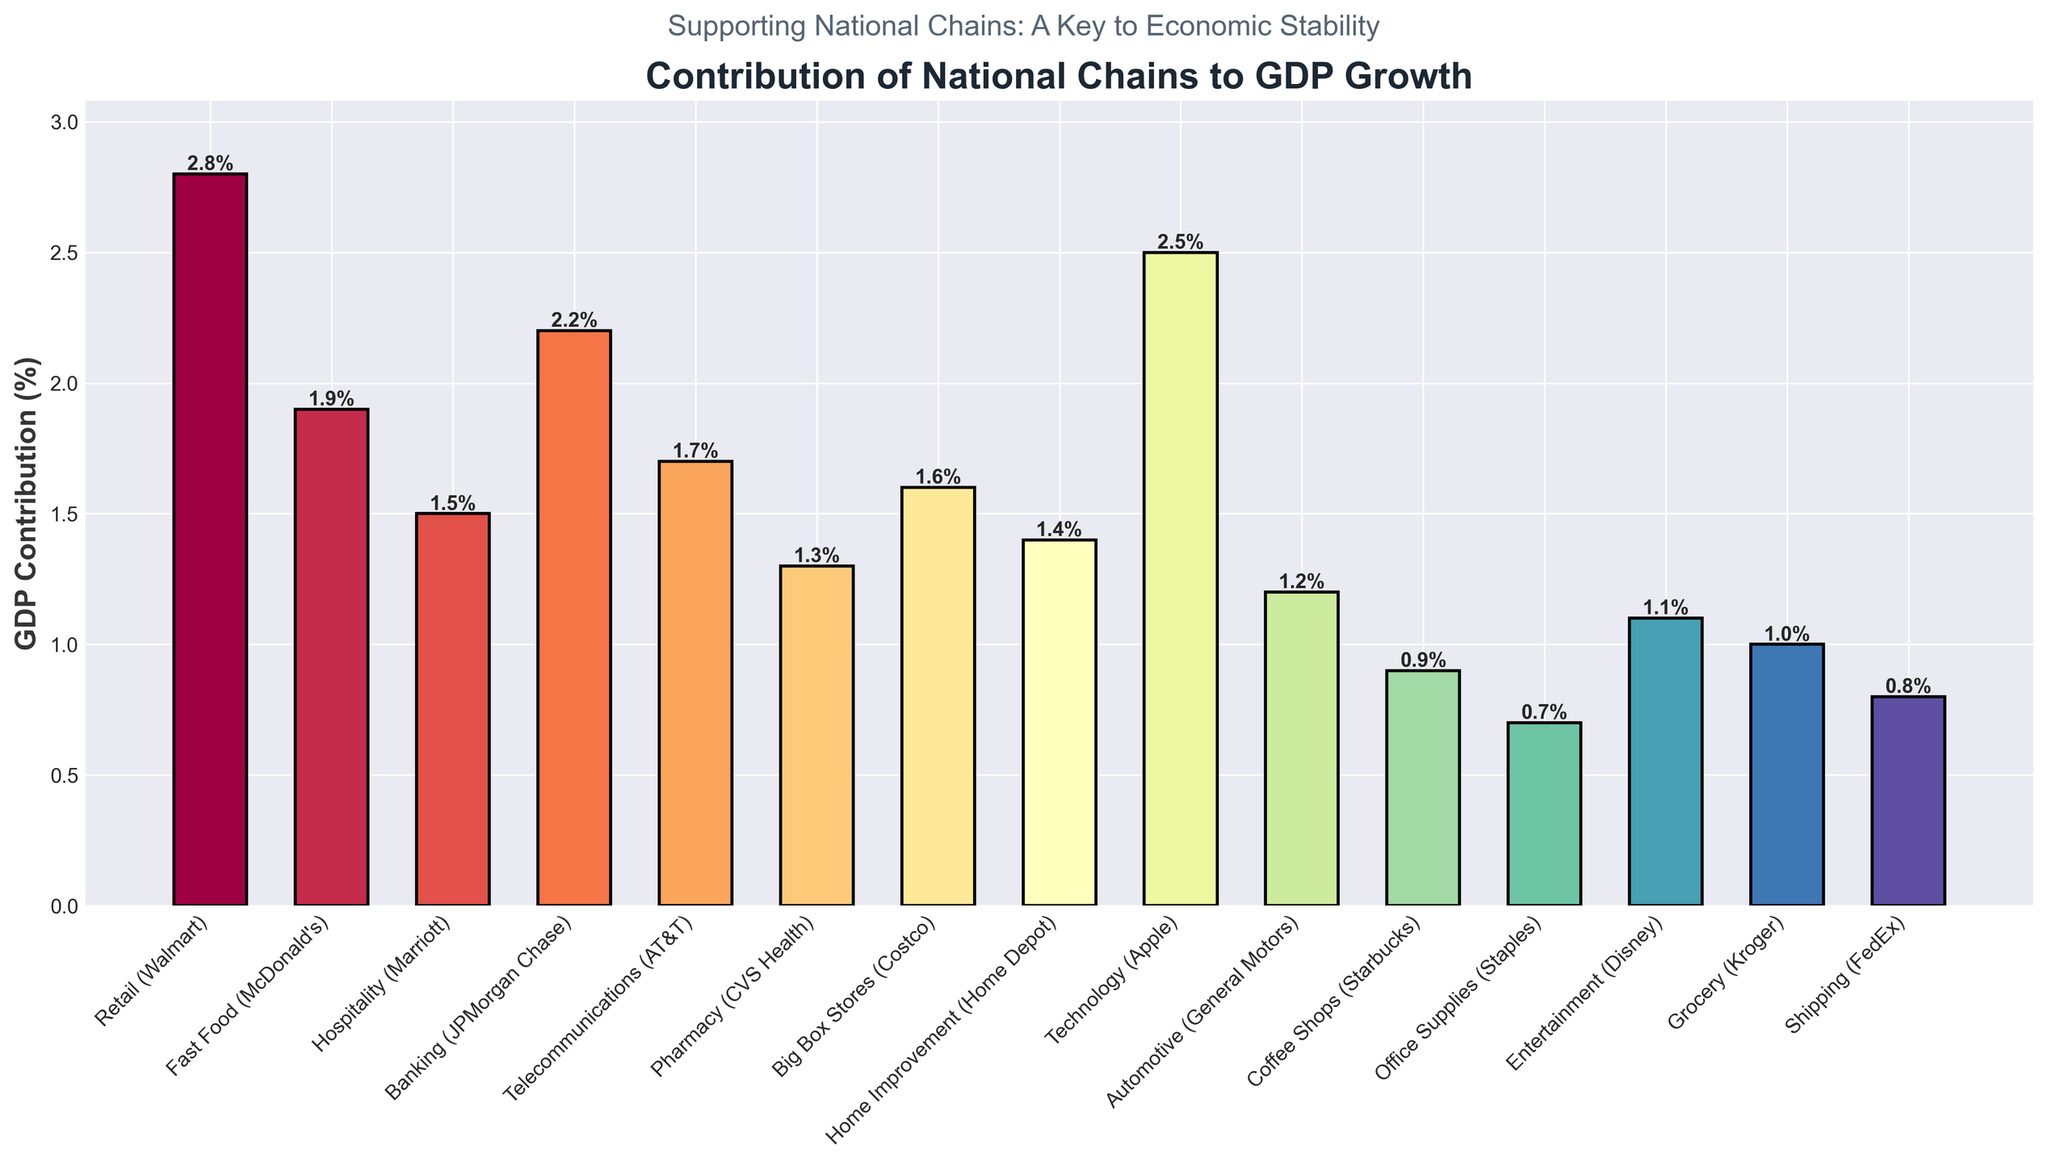Which sector has the highest GDP contribution? The height of the bar for 'Retail (Walmart)' is the tallest in the chart, indicating it has the highest GDP contribution percentage among all sectors.
Answer: Retail (Walmart) Which sector has the lowest GDP contribution? The bar representing 'Office Supplies (Staples)' is the shortest in the chart, indicating it has the lowest GDP contribution percentage among all sectors listed.
Answer: Office Supplies (Staples) What is the combined GDP contribution of the 'Banking' and 'Technology' sectors? The GDP contribution of Banking (JPMorgan Chase) is 2.2%, and Technology (Apple) is 2.5%. Adding these values together gives 2.2% + 2.5% = 4.7%.
Answer: 4.7% Compare the GDP contribution of 'Fast Food (McDonald’s)' and 'Hospitality (Marriott)'. Which one is higher and by how much? The bar for 'Fast Food (McDonald's)' shows a GDP contribution of 1.9%, while 'Hospitality (Marriott)' shows 1.5%. The difference is 1.9% - 1.5% = 0.4%.
Answer: Fast Food (McDonald's) by 0.4% What is the average GDP contribution of the 'Pharmacy', 'Home Improvement', and 'Automotive' sectors? The GDP contributions are 1.3% (Pharmacy), 1.4% (Home Improvement), and 1.2% (Automotive). The sum is 1.3% + 1.4% + 1.2% = 3.9%, and the average is 3.9% / 3 = 1.3%.
Answer: 1.3% How many sectors have a GDP contribution greater than 2%? The bars for 'Retail (Walmart)' (2.8%), 'Banking (JPMorgan Chase)' (2.2%), and 'Technology (Apple)' (2.5%) are all above the 2% mark.
Answer: 3 Which sector has a GDP contribution closest to 1%? The bar for 'Grocery (Kroger)' shows a GDP contribution of 1.0%, which is closest to 1%.
Answer: Grocery (Kroger) What is the difference in GDP contribution between the highest and lowest contributing sectors? The highest GDP contribution is 'Retail (Walmart)' at 2.8%, and the lowest is 'Office Supplies (Staples)' at 0.7%. The difference is 2.8% - 0.7% = 2.1%.
Answer: 2.1% Is the GDP contribution of the 'Telecommunications' sector more or less than the 'Fast Food' sector? The bar for 'Telecommunications (AT&T)' shows 1.7%, while 'Fast Food (McDonald’s)' shows 1.9%. Telecommunications is less by 0.2%.
Answer: Less What's the total GDP contribution percentage of all sectors combined? Summing the GDP contributions of all listed sectors: 2.8% + 1.9% + 1.5% + 2.2% + 1.7% + 1.3% + 1.6% + 1.4% + 2.5% + 1.2% + 0.9% + 0.7% + 1.1% + 1.0% + 0.8% = 22.6%.
Answer: 22.6% 